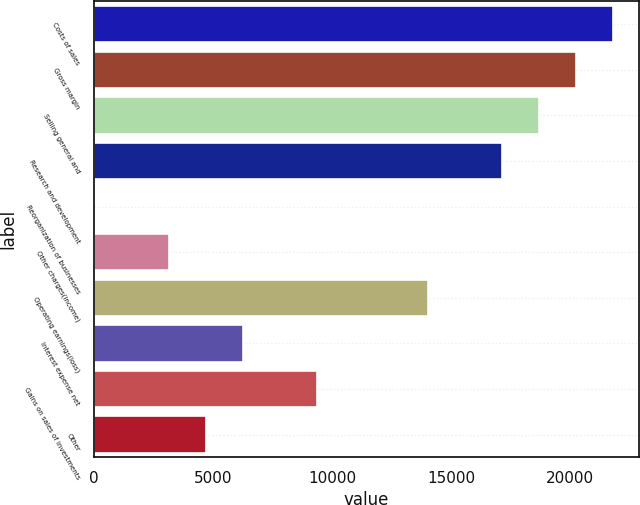Convert chart to OTSL. <chart><loc_0><loc_0><loc_500><loc_500><bar_chart><fcel>Costs of sales<fcel>Gross margin<fcel>Selling general and<fcel>Research and development<fcel>Reorganization of businesses<fcel>Other charges(income)<fcel>Operating earnings(loss)<fcel>Interest expense net<fcel>Gains on sales of investments<fcel>Other<nl><fcel>21814<fcel>20257.5<fcel>18701<fcel>17144.5<fcel>23<fcel>3136<fcel>14031.5<fcel>6249<fcel>9362<fcel>4692.5<nl></chart> 